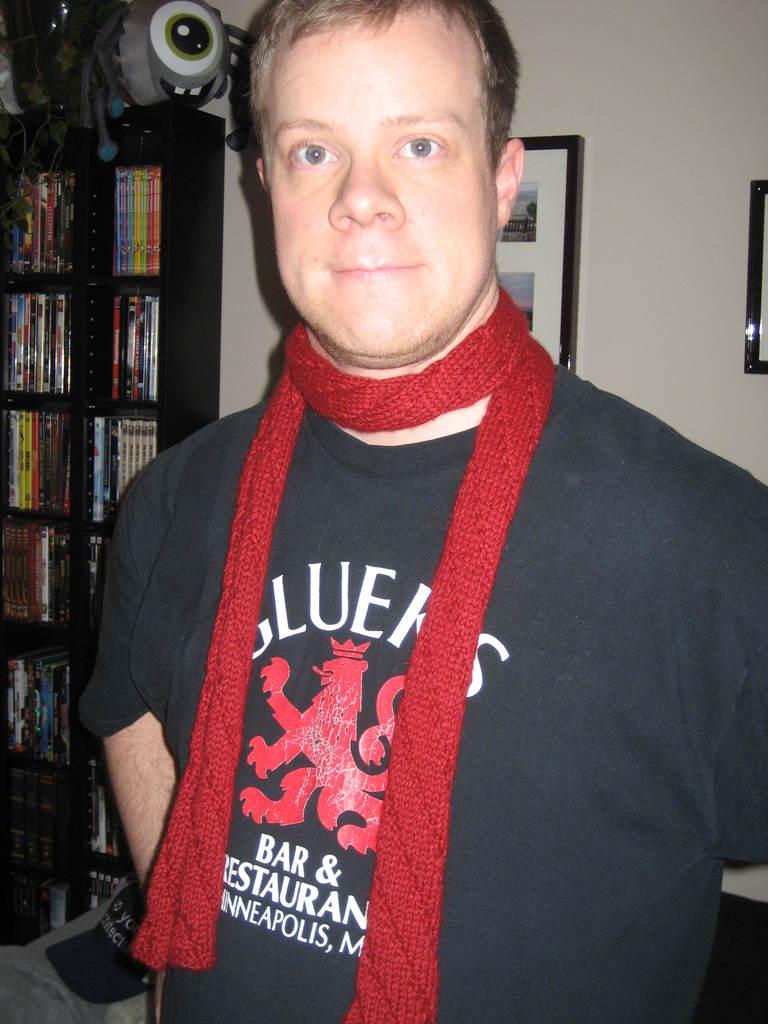Where is the bar located?
Give a very brief answer. Minneapolis. 